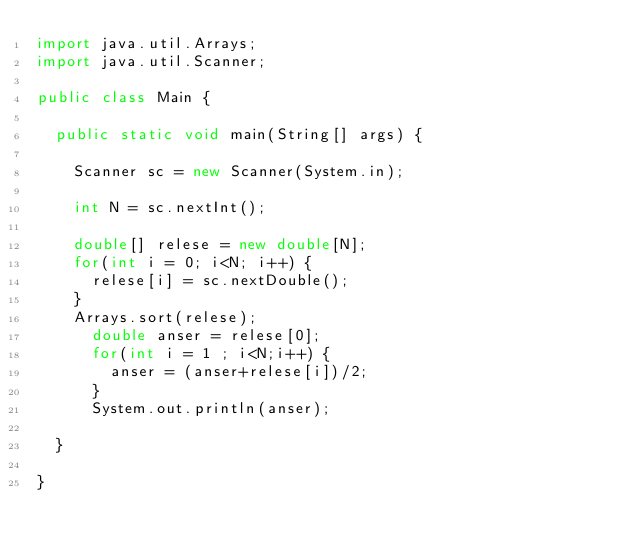<code> <loc_0><loc_0><loc_500><loc_500><_Java_>import java.util.Arrays;
import java.util.Scanner;

public class Main {

	public static void main(String[] args) {

		Scanner sc = new Scanner(System.in);

		int N = sc.nextInt();

		double[] relese = new double[N];
		for(int i = 0; i<N; i++) {
			relese[i] = sc.nextDouble();
		}
		Arrays.sort(relese);
			double anser = relese[0];
			for(int i = 1 ; i<N;i++) {
				anser = (anser+relese[i])/2;
			}
			System.out.println(anser);

	}

}
</code> 